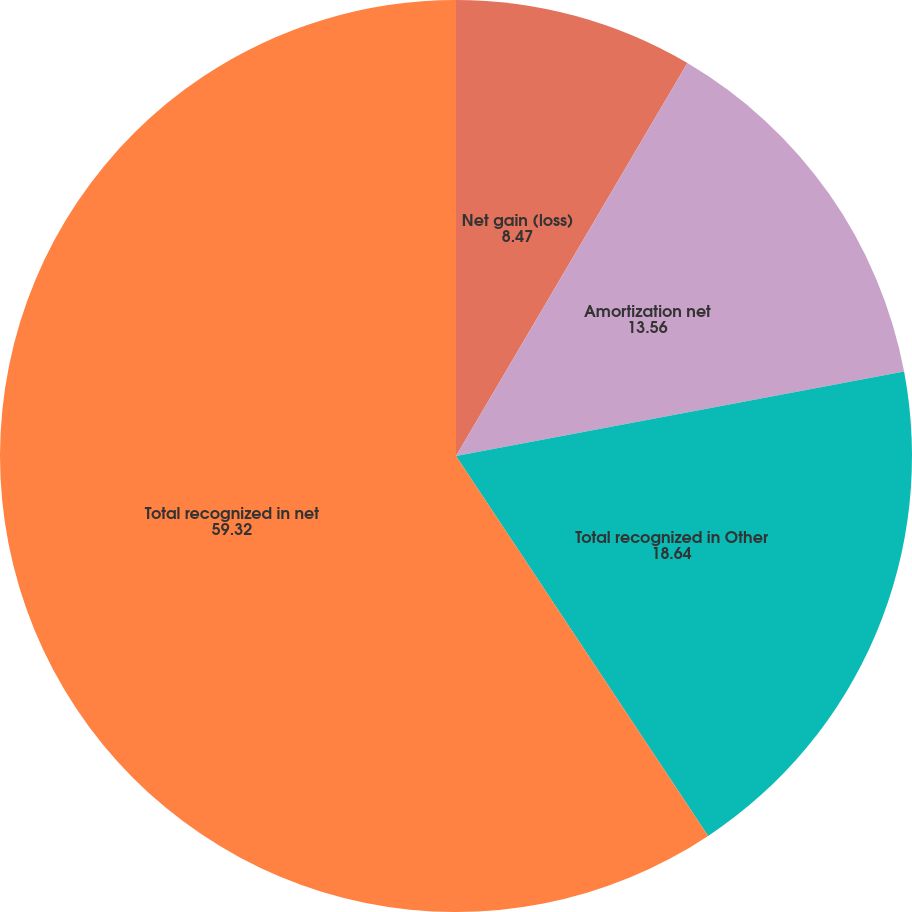<chart> <loc_0><loc_0><loc_500><loc_500><pie_chart><fcel>Net gain (loss)<fcel>Amortization net<fcel>Total recognized in Other<fcel>Total recognized in net<nl><fcel>8.47%<fcel>13.56%<fcel>18.64%<fcel>59.32%<nl></chart> 